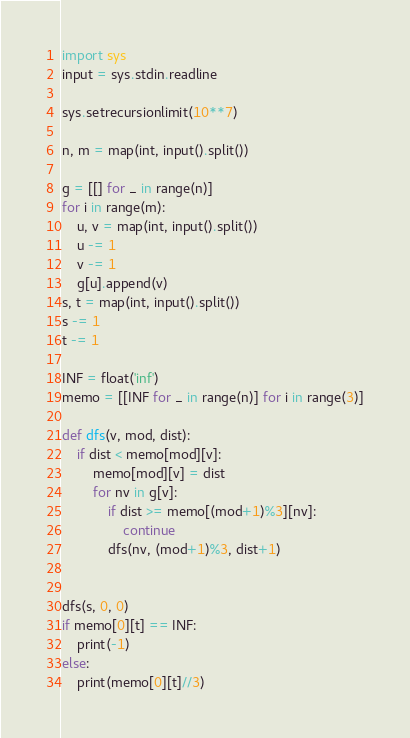<code> <loc_0><loc_0><loc_500><loc_500><_Python_>import sys
input = sys.stdin.readline

sys.setrecursionlimit(10**7)

n, m = map(int, input().split())

g = [[] for _ in range(n)]
for i in range(m):
    u, v = map(int, input().split())
    u -= 1
    v -= 1
    g[u].append(v)
s, t = map(int, input().split())
s -= 1
t -= 1

INF = float('inf')
memo = [[INF for _ in range(n)] for i in range(3)]

def dfs(v, mod, dist):
    if dist < memo[mod][v]:
        memo[mod][v] = dist
        for nv in g[v]:
            if dist >= memo[(mod+1)%3][nv]:
                continue
            dfs(nv, (mod+1)%3, dist+1)


dfs(s, 0, 0)
if memo[0][t] == INF:
    print(-1)
else:
    print(memo[0][t]//3)
</code> 